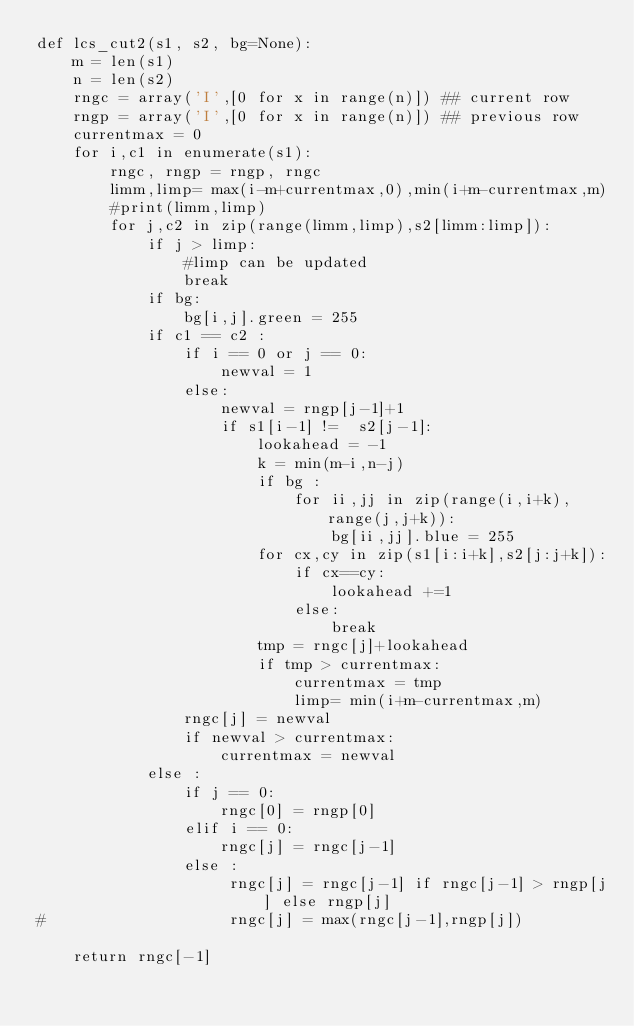Convert code to text. <code><loc_0><loc_0><loc_500><loc_500><_Python_>def lcs_cut2(s1, s2, bg=None):    
    m = len(s1)
    n = len(s2) 
    rngc = array('I',[0 for x in range(n)]) ## current row
    rngp = array('I',[0 for x in range(n)]) ## previous row
    currentmax = 0
    for i,c1 in enumerate(s1):
        rngc, rngp = rngp, rngc
        limm,limp= max(i-m+currentmax,0),min(i+m-currentmax,m)
        #print(limm,limp) 
        for j,c2 in zip(range(limm,limp),s2[limm:limp]):
            if j > limp:
                #limp can be updated
                break
            if bg:
                bg[i,j].green = 255
            if c1 == c2 : 
                if i == 0 or j == 0:
                    newval = 1
                else:
                    newval = rngp[j-1]+1
                    if s1[i-1] !=  s2[j-1]:
                        lookahead = -1
                        k = min(m-i,n-j)
                        if bg :
                            for ii,jj in zip(range(i,i+k),range(j,j+k)):
                                bg[ii,jj].blue = 255
                        for cx,cy in zip(s1[i:i+k],s2[j:j+k]):
                            if cx==cy:
                                lookahead +=1
                            else:
                                break
                        tmp = rngc[j]+lookahead 
                        if tmp > currentmax:
                            currentmax = tmp
                            limp= min(i+m-currentmax,m)
                rngc[j] = newval
                if newval > currentmax:
                    currentmax = newval
            else :
                if j == 0:
                    rngc[0] = rngp[0]
                elif i == 0: 
                    rngc[j] = rngc[j-1]
                else :
                     rngc[j] = rngc[j-1] if rngc[j-1] > rngp[j] else rngp[j]
#                    rngc[j] = max(rngc[j-1],rngp[j])

    return rngc[-1]</code> 